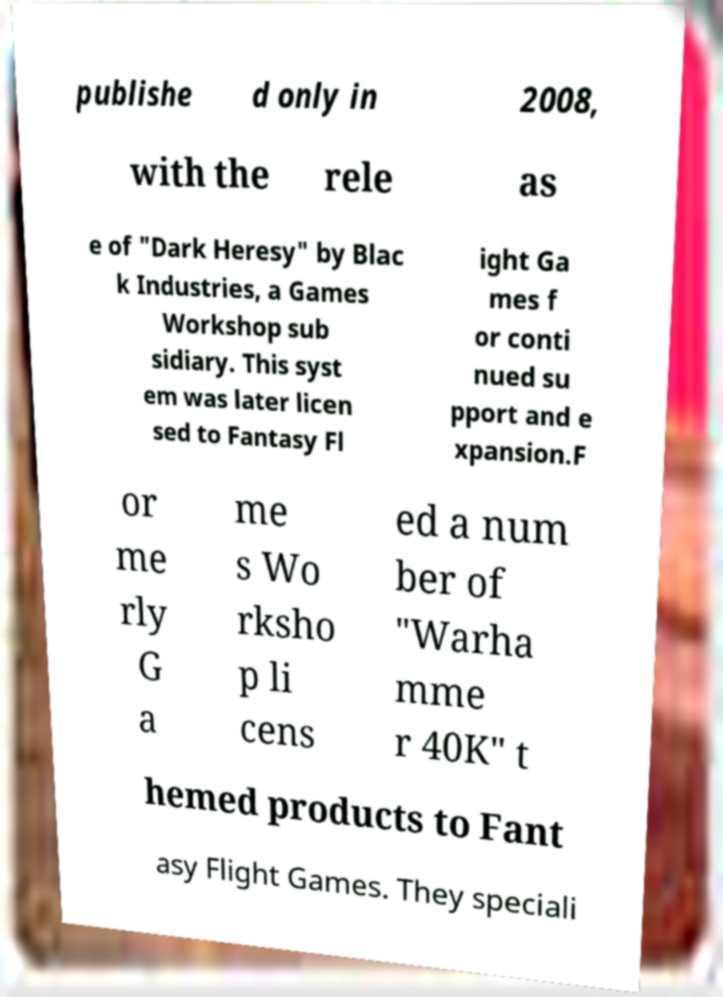Can you read and provide the text displayed in the image?This photo seems to have some interesting text. Can you extract and type it out for me? publishe d only in 2008, with the rele as e of "Dark Heresy" by Blac k Industries, a Games Workshop sub sidiary. This syst em was later licen sed to Fantasy Fl ight Ga mes f or conti nued su pport and e xpansion.F or me rly G a me s Wo rksho p li cens ed a num ber of "Warha mme r 40K" t hemed products to Fant asy Flight Games. They speciali 